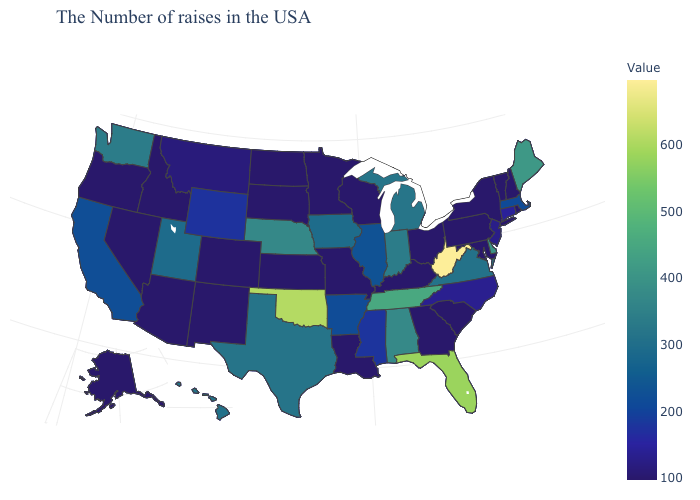Among the states that border Oklahoma , which have the highest value?
Answer briefly. Texas. Does Oregon have the highest value in the West?
Answer briefly. No. Does California have a lower value than New Jersey?
Give a very brief answer. No. 